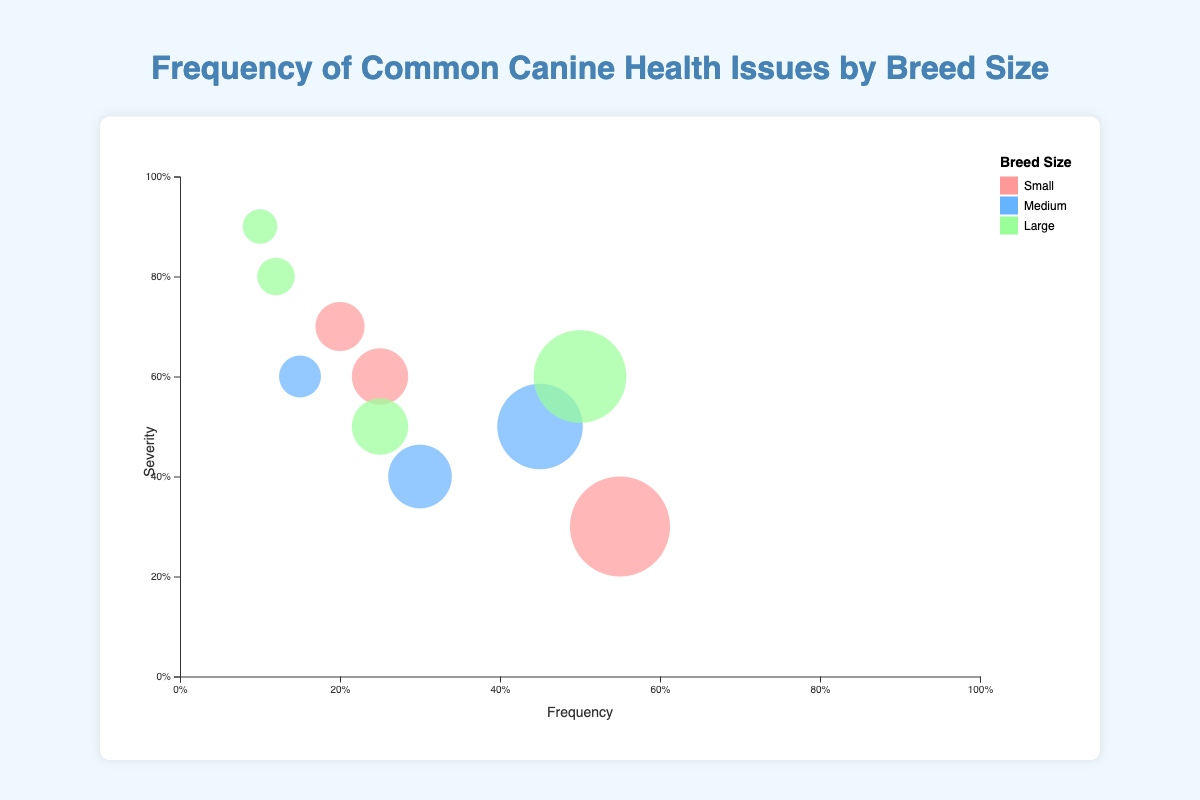What is the title of the chart? The title is displayed at the top of the chart and reads "Frequency of Common Canine Health Issues by Breed Size".
Answer: Frequency of Common Canine Health Issues by Breed Size Which breed size has the most health issues displayed in the chart? By examining the different colors representing breed sizes and counting the bubbles, Small breed size has three health issues (Dental Disease, Luxating Patella, and Tracheal Collapse), Medium breed size has three issues (Hip Dysplasia, Epilepsy, and Hypothyroidism), and Large breed size has four issues (Hip Dysplasia, Bloat, Elbow Dysplasia, and Osteosarcoma).
Answer: Large Which canine health issue has the highest frequency according to the chart? The bubble with the highest position on the frequency axis (x-axis) represents the issue with the highest frequency. Dental Disease in Small breed size has the highest frequency at 0.55.
Answer: Dental Disease What are the frequency and severity of Luxating Patella in small breed size? Locate the bubble representing Luxating Patella within Small breed size. The data shows frequency as 0.25 and severity as 0.6.
Answer: Frequency: 0.25, Severity: 0.60 Which health issue has the highest severity and what is its breed size? The bubble with the extreme leftmost position on the severity axis (y-axis) represents the issue with the highest severity. Bloat in Large breed size has the highest severity at 0.9.
Answer: Bloat, Large Does Hip Dysplasia appear for multiple breed sizes and if so, what are the differences in frequency? Hip Dysplasia is represented by two bubbles in the chart for Medium and Large breed sizes. Medium breed size has a frequency of 0.45, while Large breed size has a frequency of 0.50.
Answer: Yes, Medium: 0.45, Large: 0.50 What is the combined severity of all health issues within Medium breed size? Extract severities for each health issue within Medium breed size: Hip Dysplasia (0.5), Epilepsy (0.6), and Hypothyroidism (0.4). Add these severities together: 0.5 + 0.6 + 0.4 = 1.5.
Answer: 1.5 Which health issue in Large breed size has the lowest frequency and what is its severity? Identify the bubble representing Large breed issues and find the one with the lowest position on the x-axis (frequency). Bloat has the lowest frequency at 0.10 and severity 0.9.
Answer: Bloat, Severity: 0.9 How many health issues have a frequency greater than 0.2? Count the number of bubbles that are positioned to the right of the 0.2 value on the x-axis. There are six issues: Dental Disease, Hip Dysplasia (Medium), Hypothyroidism, Hip Dysplasia (Large), Luxating Patella, and Elbow Dysplasia.
Answer: 6 